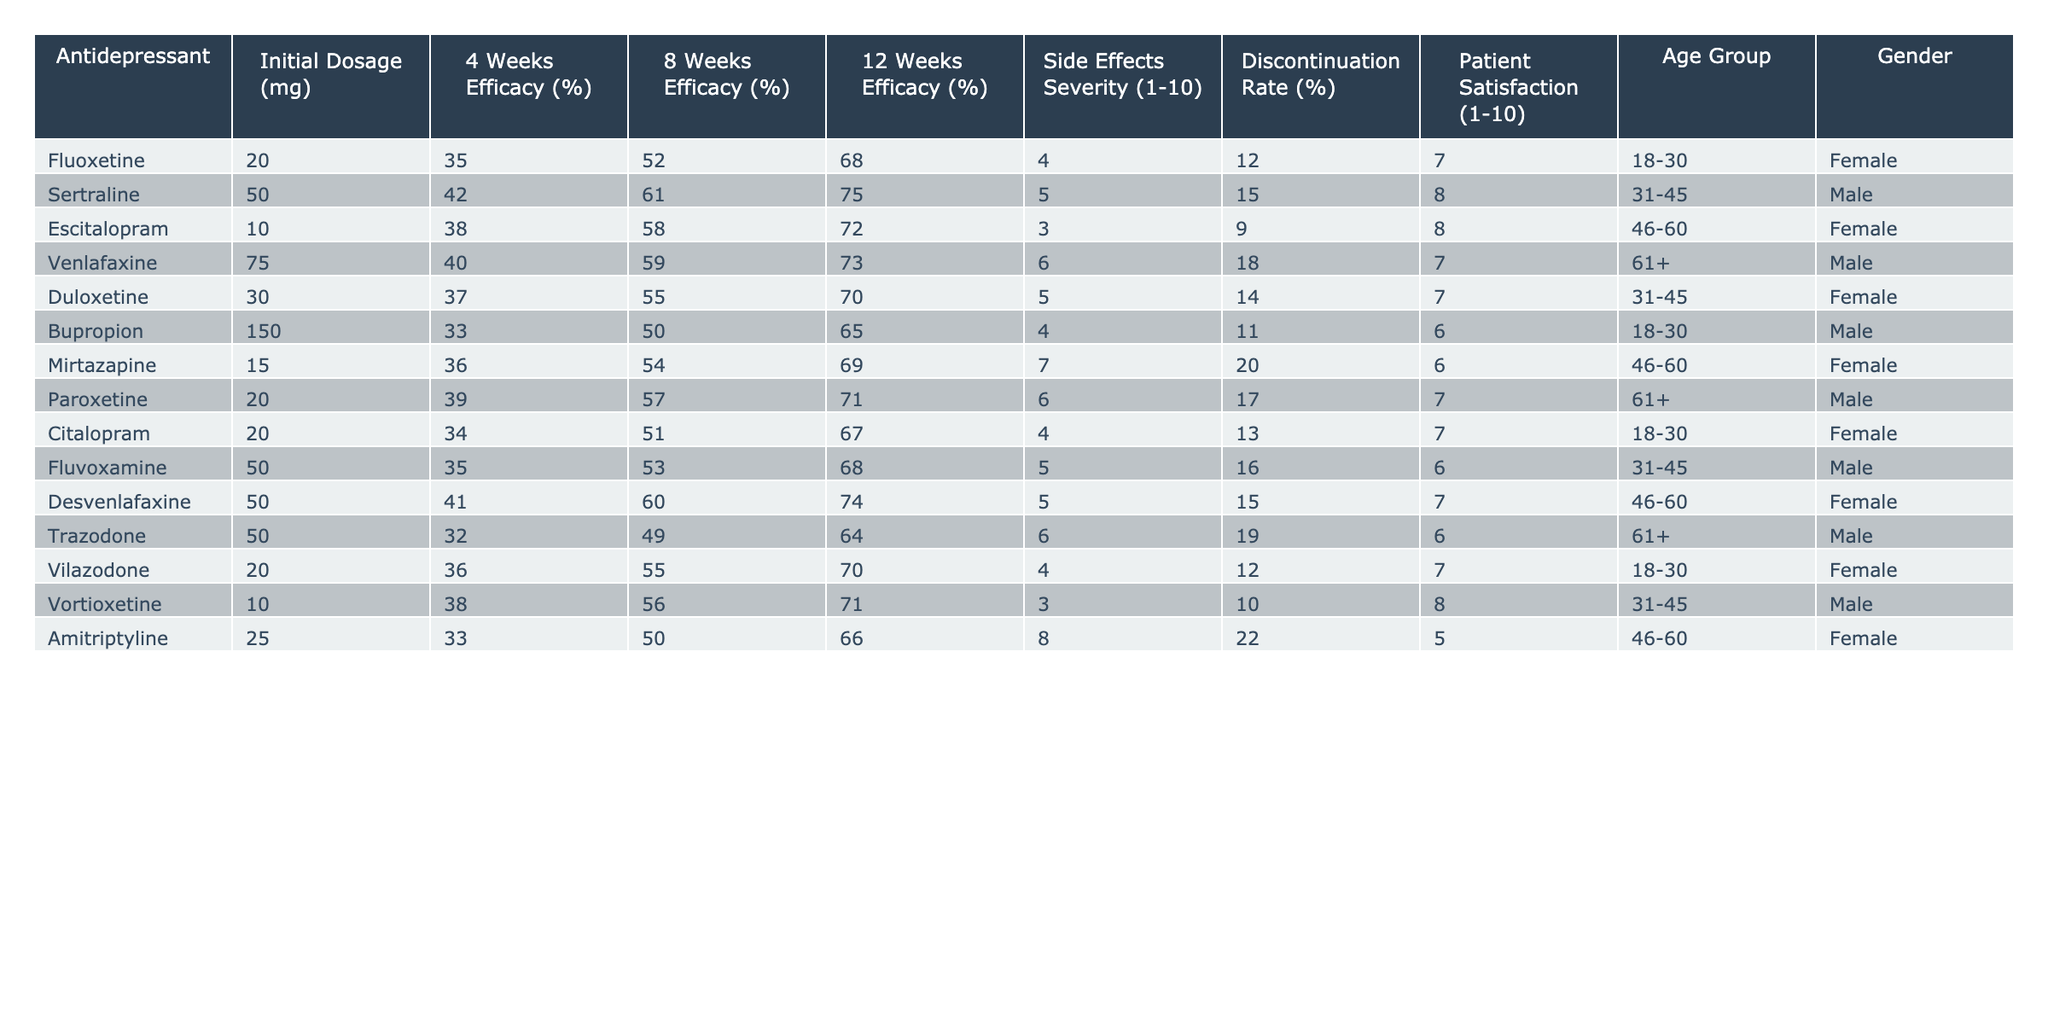What is the highest efficacy percentage at 12 weeks among the antidepressants listed? Looking at the "12 Weeks Efficacy (%)" column, the highest percentage is 75%, corresponding to Sertraline.
Answer: 75% What was the initial dosage (in mg) of Venlafaxine? In the "Initial Dosage (mg)" column, Venlafaxine has an initial dosage of 75 mg.
Answer: 75 mg Which antidepressant has the lowest side effects severity? By checking the "Side Effects Severity (1-10)" column, the lowest value is 3, which is associated with Escitalopram and Vortioxetine.
Answer: 3 What is the average discontinuation rate for all the antidepressants? To find the average, add all the discontinuation rates (12 + 15 + 9 + 18 + 14 + 11 + 20 + 17 + 13 + 16 + 15 + 19 + 12 + 22) =  17.5, and divide by the number of antidepressants (14). So, the average discontinuation rate is approximately 17.5%.
Answer: 17.5% Are there any antidepressants in the age group of 61+ that have a patient satisfaction rating of 8 or higher? Checking the data for the age group of 61+, we find that none of the antidepressants listed (Venlafaxine, Paroxetine, Trazodone) have a patient satisfaction rating of 8 or higher; the maximum is 7.
Answer: No Which antidepressants show a 4-week efficacy of at least 40%? Looking through the "4 Weeks Efficacy (%)" column, the antidepressants that meet this criterion are Sertraline, Escitalopram, Venlafaxine, Duloxetine, Desvenlafaxine, and others.
Answer: Sertraline, Escitalopram, Venlafaxine, Duloxetine, Desvenlafaxine What is the difference in patient satisfaction between the highest rating and the lowest rating? The highest patient satisfaction rating is 8 (Sertraline and Escitalopram), and the lowest is 5 (Amitriptyline). The difference is 8 - 5 = 3.
Answer: 3 Which gender primarily uses Fluoxetine based on the data? Referring to the "Gender" column, Fluoxetine is used by females.
Answer: Female Identify the antidepressant with the combination of the highest 12-week efficacy and side effects severity. The highest 12-week efficacy is 75% (Sertraline), which has a side effects severity of 5. Checking other antidepressants, no one has both a higher efficacy and severity combined. Thus, Sertraline holds the top position for both metrics.
Answer: Sertraline How many antidepressants have an initial dosage of less than 20 mg? Counting the entries, Fluoxetine (20), Bupropion (150), and Mirtazapine (15) meet this criterion; however, since Fluoxetine has the minimum which is equal to 20 mg and can not be counted, only one falls under the 20 mg category.
Answer: 1 